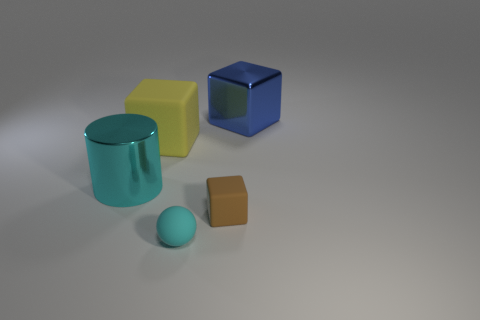Add 3 large gray shiny blocks. How many objects exist? 8 Subtract all blocks. How many objects are left? 2 Add 5 blue cubes. How many blue cubes are left? 6 Add 2 large green rubber cubes. How many large green rubber cubes exist? 2 Subtract 0 gray cylinders. How many objects are left? 5 Subtract all big cylinders. Subtract all tiny rubber objects. How many objects are left? 2 